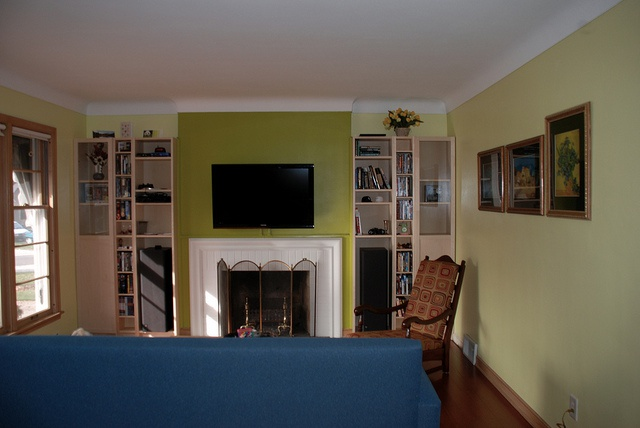Describe the objects in this image and their specific colors. I can see couch in gray, navy, black, and darkblue tones, tv in gray, black, and olive tones, chair in gray, black, and maroon tones, book in gray, black, and maroon tones, and potted plant in gray, olive, and black tones in this image. 